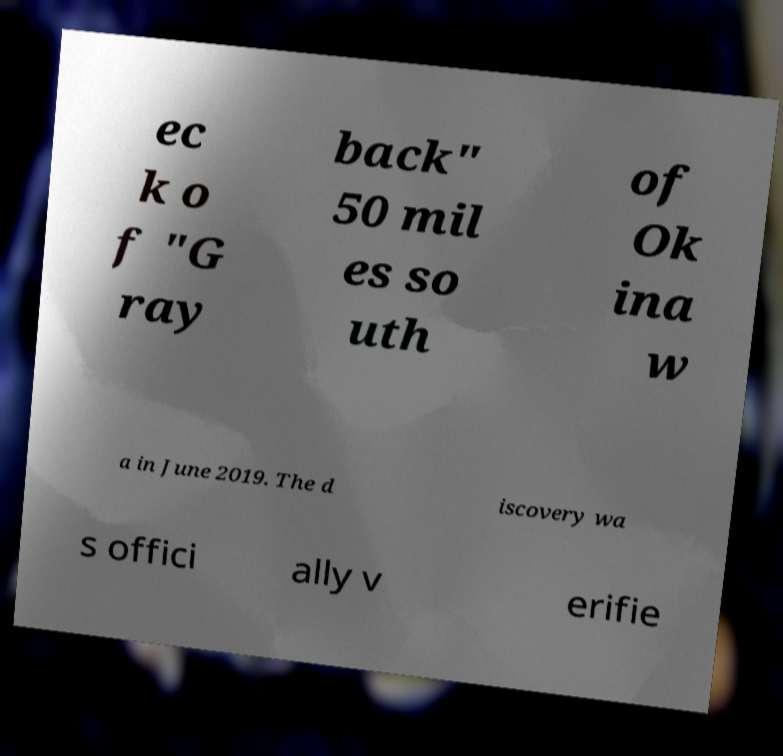What messages or text are displayed in this image? I need them in a readable, typed format. ec k o f "G ray back" 50 mil es so uth of Ok ina w a in June 2019. The d iscovery wa s offici ally v erifie 